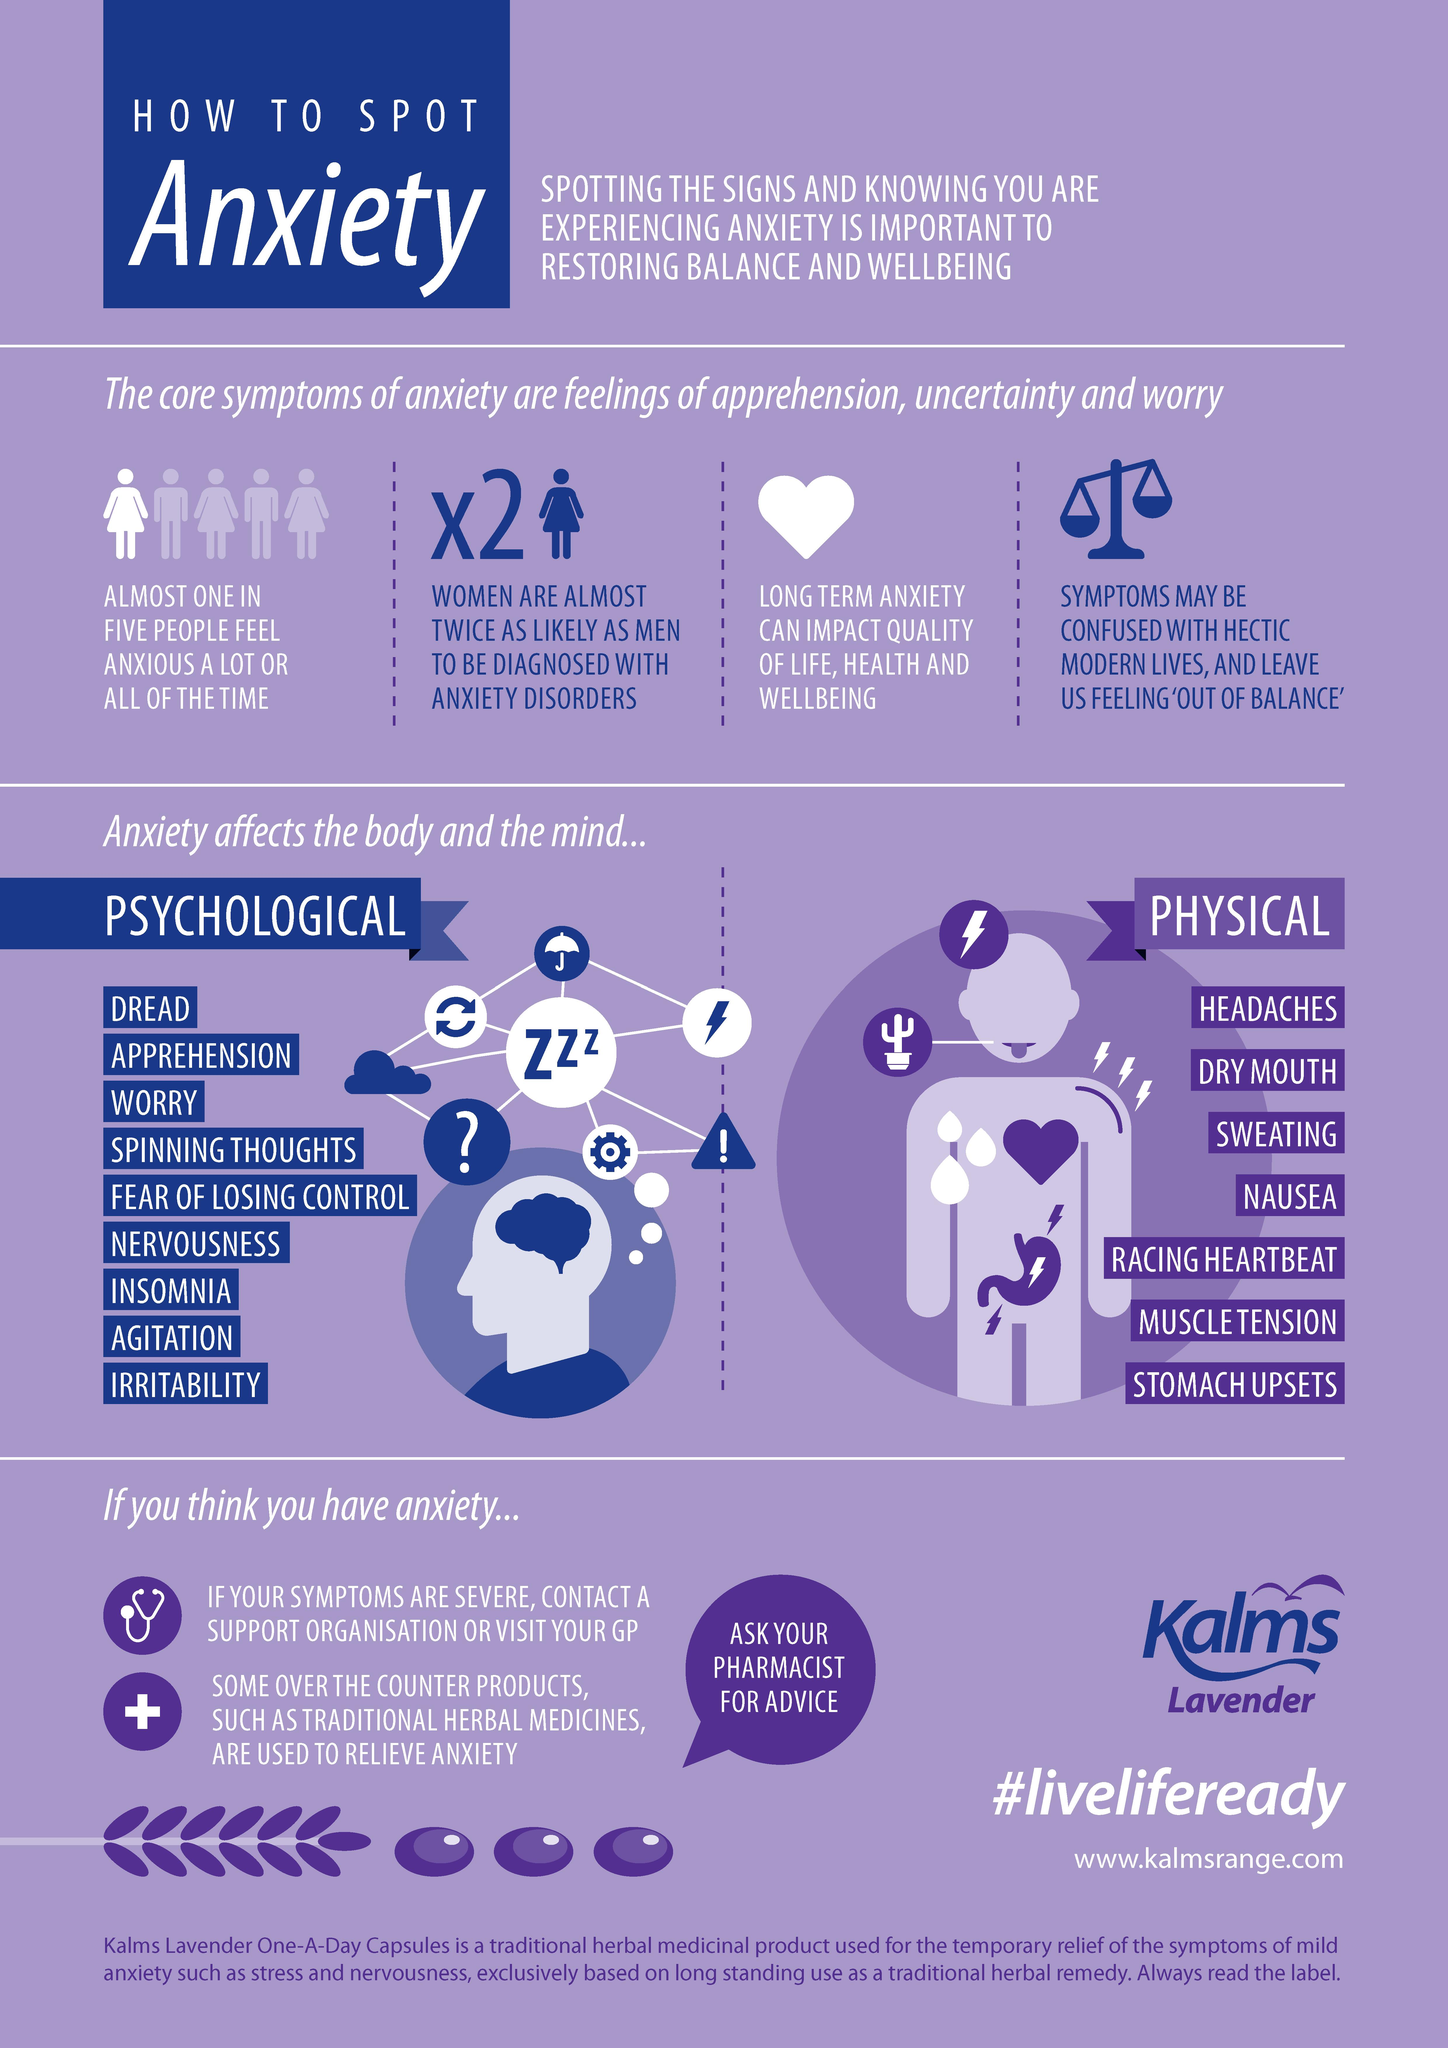Specify some key components in this picture. Anxiety has several physical implications that can significantly impact a person's health and well-being. In fact, research suggests that anxiety can cause up to 7 different physical implications. Nine psychological implications result from anxiety. 